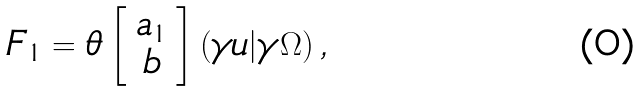Convert formula to latex. <formula><loc_0><loc_0><loc_500><loc_500>F _ { 1 } = \theta \left [ \begin{array} { c } a _ { 1 } \\ b \end{array} \right ] \left ( \gamma u | \gamma \Omega \right ) ,</formula> 